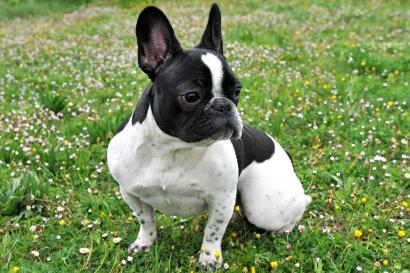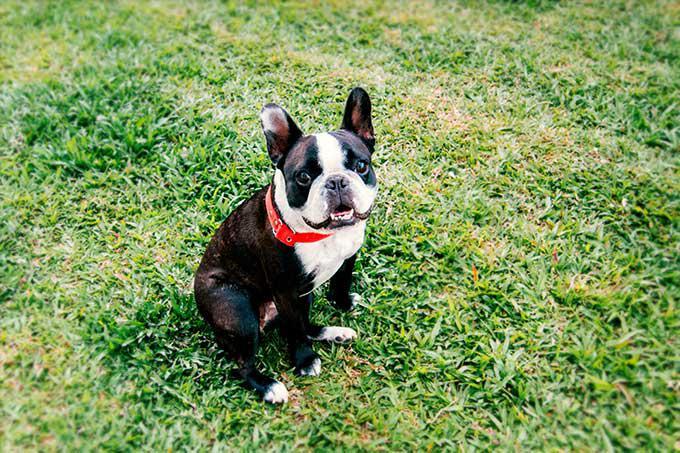The first image is the image on the left, the second image is the image on the right. Evaluate the accuracy of this statement regarding the images: "One of the images does not show the entire body of the dog.". Is it true? Answer yes or no. No. 